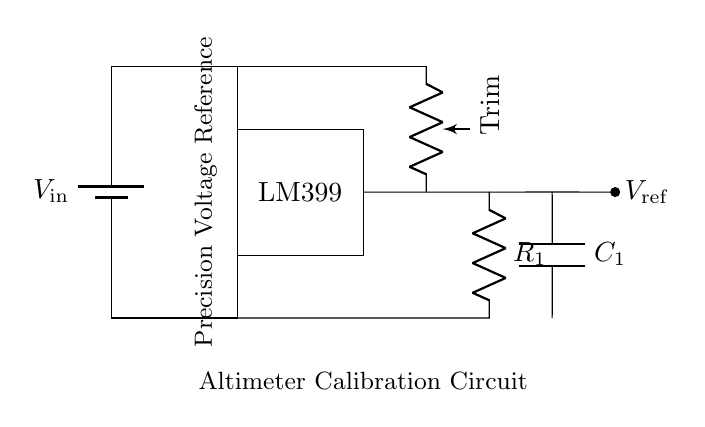What is the purpose of the LM399 in this circuit? The LM399 serves as a precision voltage reference, providing a stable output voltage for calibration purposes. This is evident as it's labeled in the circuit diagram as a key component for maintaining consistent voltage levels.
Answer: Precision voltage reference What type of component is R1 in this circuit? R1 is a resistor, which can be identified in the circuit diagram as the component labeled with "R" connected to the output of the reference IC. Its role is likely to limit current or set a reference.
Answer: Resistor What is the output voltage reference denoted as? The output voltage reference is labeled as "V_ref" in the circuit diagram, indicating this is the voltage level maintained by the LM399 for calibration.
Answer: V_ref Why is there a trimmer potentiometer in the circuit? The trimmer potentiometer is used for fine-tuning the output voltage. This is concluded from its role in adjusting the resistance in the feedback loop, which directly affects the voltage reference output for calibration adjustments.
Answer: Fine-tuning Which component ensures stability in this circuit? The capacitor, labeled C1, ensures stability in the voltage reference output by filtering noise and providing a stable load, which is crucial for accurate altimeter readings.
Answer: Capacitor What is the primary application of this circuit? The primary application is indicated by the label "Altimeter Calibration Circuit," suggesting it is designed specifically for setting and calibrating altimeter equipment used in aviation.
Answer: Altimeter calibration 